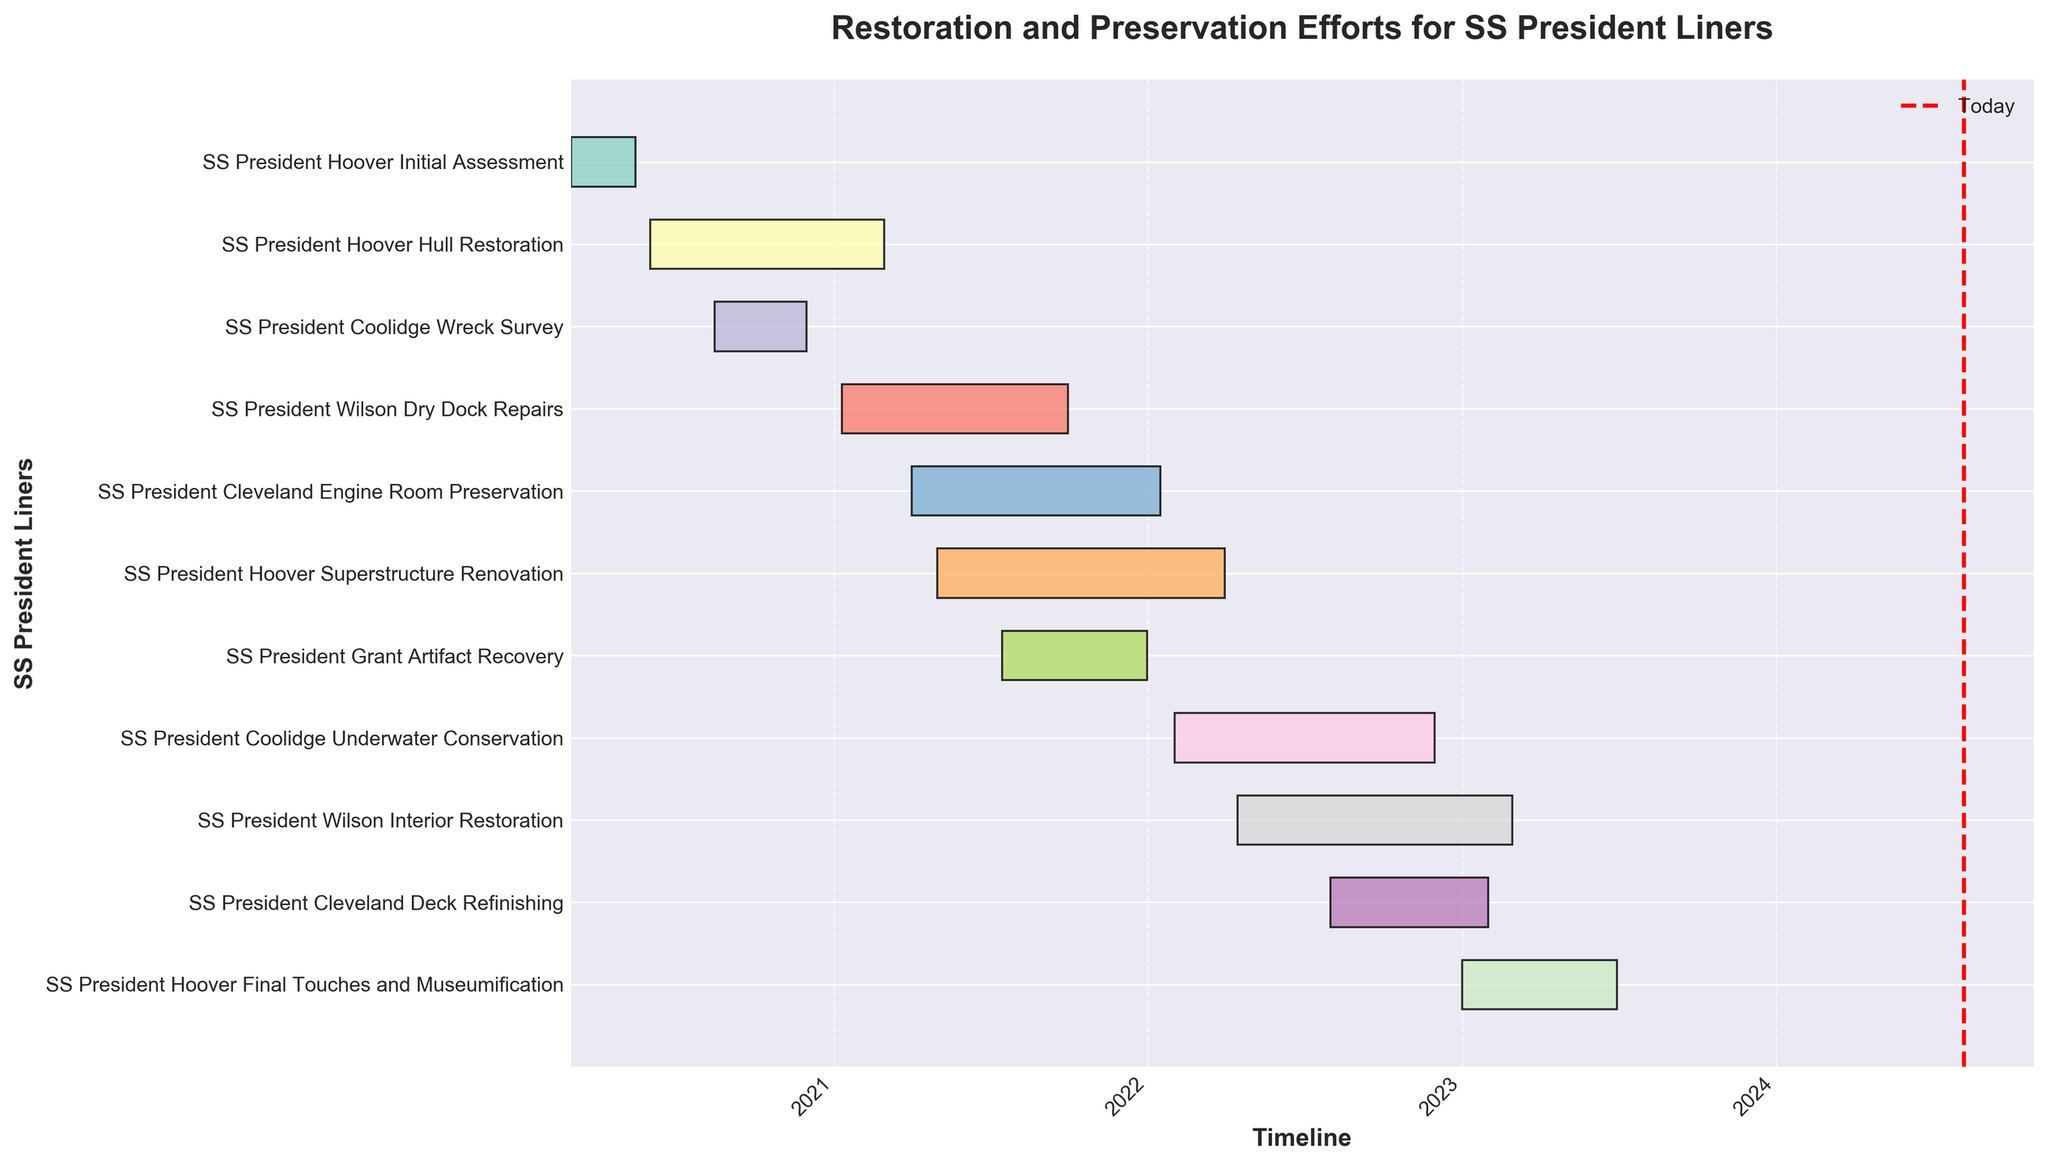What is the title of the Gantt Chart? The title of the Gantt Chart is a key element that provides context to the viewer about what the chart is representing. It is usually located at the top of the chart.
Answer: Restoration and Preservation Efforts for SS President Liners What is the task with the longest duration? To find the task with the longest duration, compare the time span from the start date to the end date for each task.
Answer: SS President Hoover Hull Restoration When was the SS President Coolidge's Wreck Survey conducted? This involves identifying the task related to SS President Coolidge's Wreck Survey and noting its start and end dates.
Answer: From 2020-08-15 to 2020-11-30 Which task started first and which one started last? To determine which tasks started first and last, compare the start dates of all tasks. The earliest start date is for the first task, and the latest start date is for the last task.
Answer: The first task is SS President Hoover Initial Assessment, and the last task is SS President Hoover Final Touches and Museumification How many tasks were ongoing in June 2021? Review the chart to see which tasks have start and end dates that overlap with June 2021. Count the number of such tasks to determine how many were ongoing.
Answer: Four tasks (SS President Hoover Hull Restoration, SS President Wilson Dry Dock Repairs, SS President Cleveland Engine Room Preservation, SS President Hoover Superstructure Renovation) Which ships had tasks that overlapped in early 2021? Identify the tasks that were active in early 2021 by checking their start and end dates against the early 2021 period. Then, note the ships these tasks relate to.
Answer: SS President Hoover, SS President Wilson, SS President Cleveland What is the duration of SS President Cleveland Engine Room Preservation? To find the duration of SS President Cleveland Engine Room Preservation, subtract the start date from the end date.
Answer: Approximately 289 days How does the duration of SS President Wilson Dry Dock Repairs compare to the SS President Coolidge Underwater Conservation? Calculate the duration of both tasks by subtracting their start dates from their end dates, and then compare the two durations.
Answer: SS President Wilson Dry Dock Repairs had a duration of approximately 263 days, and SS President Coolidge Underwater Conservation had a duration of approximately 303 days What is the range of dates covered by the entire chart? This requires identifying the earliest start date and the latest end date among all tasks to determine the overall date range.
Answer: From 2020-03-01 to 2023-06-30 Were there any tasks for SS President Hoover occurring simultaneously? If yes, which ones? Check the tasks related to SS President Hoover and see if any of them have overlapping periods in their start and end dates.
Answer: Yes, SS President Hoover Hull Restoration and SS President Hoover Superstructure Renovation from 2021-05-01 to 2021-02-28 